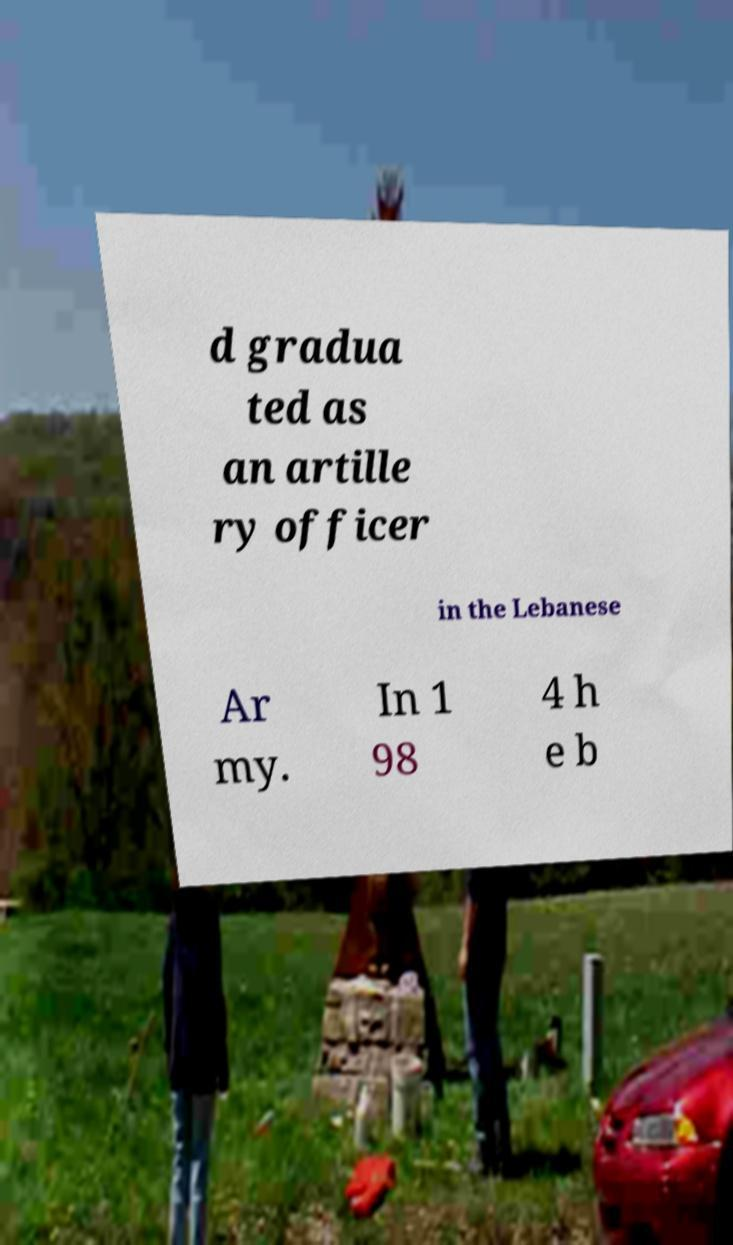For documentation purposes, I need the text within this image transcribed. Could you provide that? d gradua ted as an artille ry officer in the Lebanese Ar my. In 1 98 4 h e b 